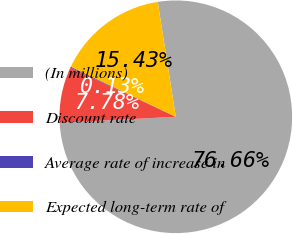Convert chart. <chart><loc_0><loc_0><loc_500><loc_500><pie_chart><fcel>(In millions)<fcel>Discount rate<fcel>Average rate of increase in<fcel>Expected long-term rate of<nl><fcel>76.66%<fcel>7.78%<fcel>0.13%<fcel>15.43%<nl></chart> 